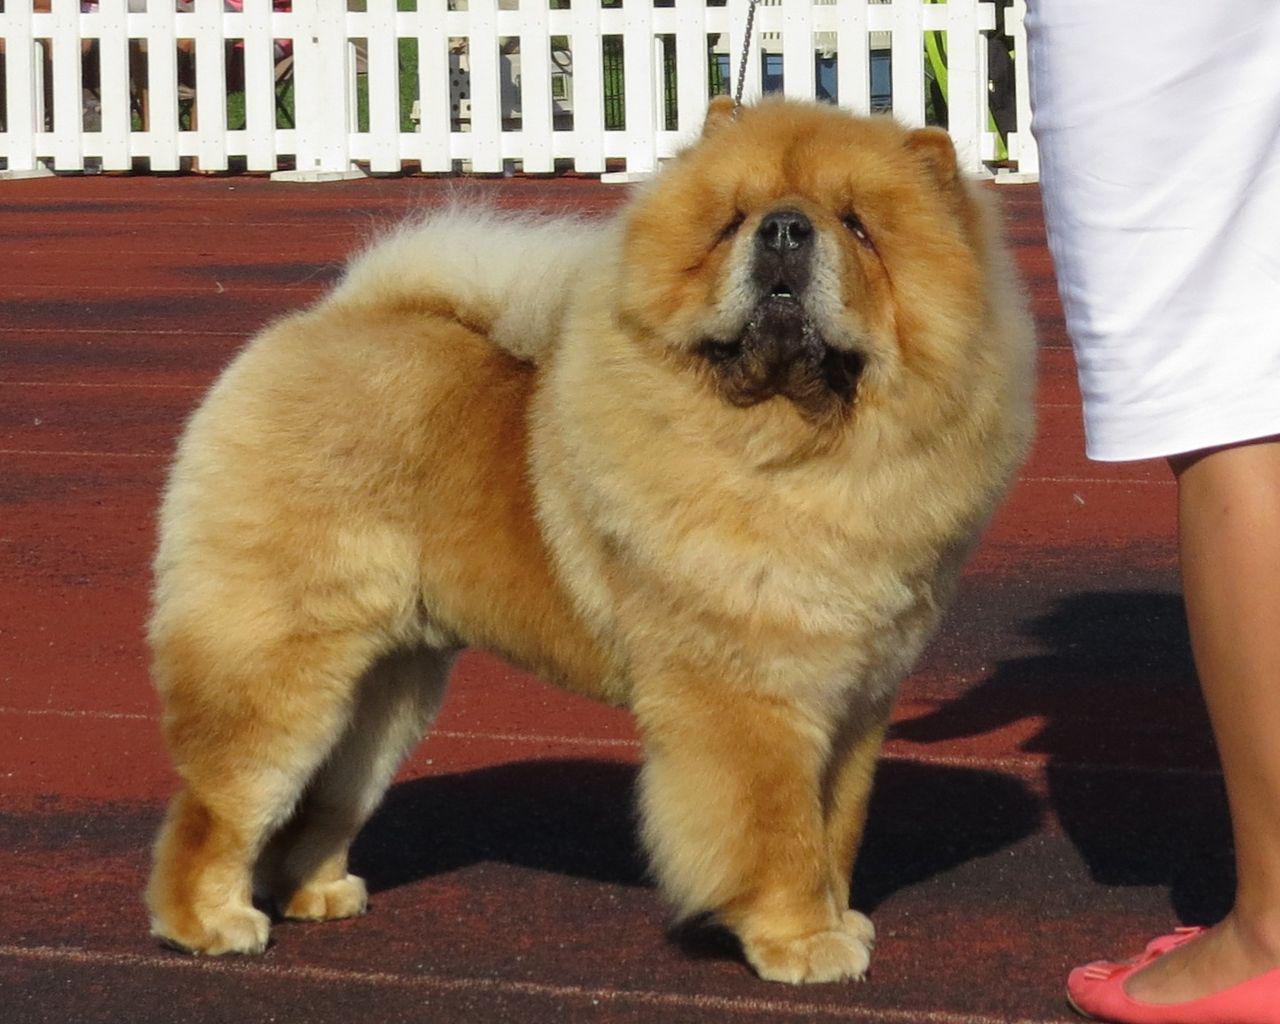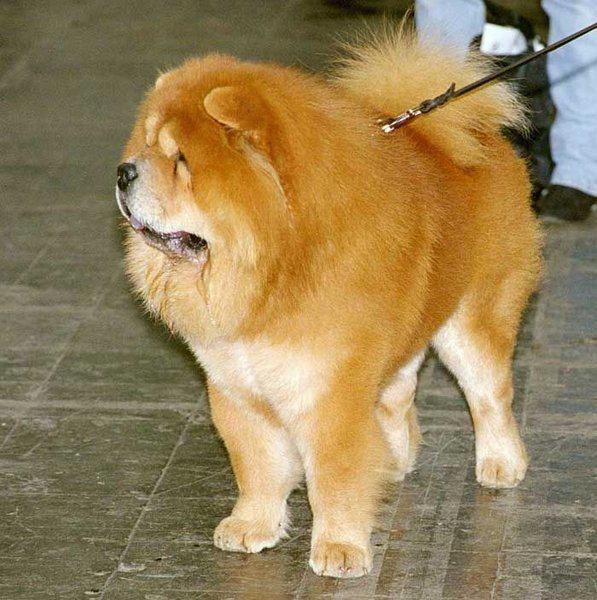The first image is the image on the left, the second image is the image on the right. Evaluate the accuracy of this statement regarding the images: "One dog is sitting and one is standing.". Is it true? Answer yes or no. No. The first image is the image on the left, the second image is the image on the right. Assess this claim about the two images: "The right image contains one chow dog attached to a leash.". Correct or not? Answer yes or no. Yes. 